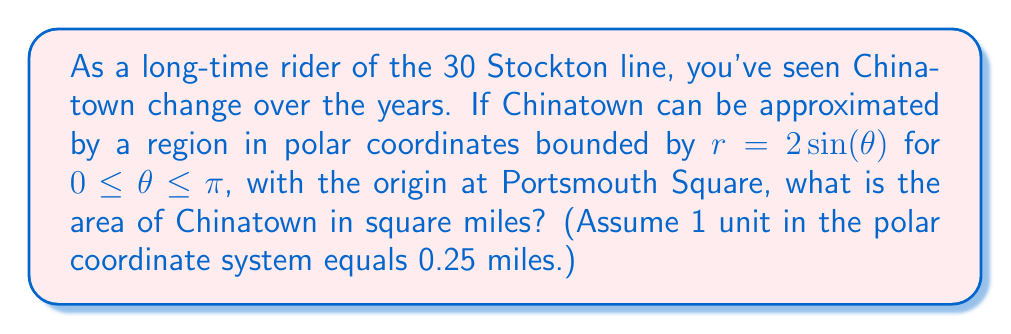Provide a solution to this math problem. To solve this problem, we'll follow these steps:

1) The general formula for the area of a region in polar coordinates is:

   $$A = \frac{1}{2} \int_a^b r^2(\theta) d\theta$$

2) In this case, $r(\theta) = 2\sin(\theta)$, $a = 0$, and $b = \pi$. Let's substitute these into our formula:

   $$A = \frac{1}{2} \int_0^\pi (2\sin(\theta))^2 d\theta$$

3) Simplify the integrand:

   $$A = \frac{1}{2} \int_0^\pi 4\sin^2(\theta) d\theta$$

4) We can use the trigonometric identity $\sin^2(\theta) = \frac{1}{2}(1 - \cos(2\theta))$:

   $$A = \frac{1}{2} \int_0^\pi 4 \cdot \frac{1}{2}(1 - \cos(2\theta)) d\theta$$
   $$A = \int_0^\pi (1 - \cos(2\theta)) d\theta$$

5) Integrate:

   $$A = [\theta - \frac{1}{2}\sin(2\theta)]_0^\pi$$

6) Evaluate the definite integral:

   $$A = (\pi - 0) - (\frac{1}{2}\sin(2\pi) - \frac{1}{2}\sin(0)) = \pi$$

7) This gives us the area in square units. To convert to square miles, we need to multiply by $(0.25)^2 = 0.0625$, as 1 unit = 0.25 miles:

   $$A_{miles} = \pi \cdot 0.0625 \approx 0.1963 \text{ square miles}$$
Answer: The area of Chinatown is approximately 0.1963 square miles. 